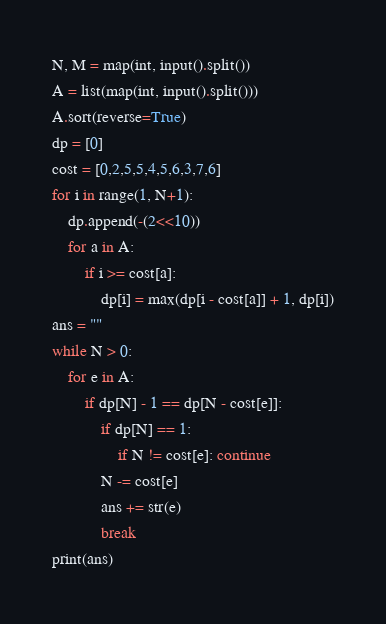Convert code to text. <code><loc_0><loc_0><loc_500><loc_500><_Python_>N, M = map(int, input().split())
A = list(map(int, input().split()))
A.sort(reverse=True)
dp = [0]
cost = [0,2,5,5,4,5,6,3,7,6]
for i in range(1, N+1):
    dp.append(-(2<<10))
    for a in A:
        if i >= cost[a]: 
            dp[i] = max(dp[i - cost[a]] + 1, dp[i])
ans = ""
while N > 0:
    for e in A:
        if dp[N] - 1 == dp[N - cost[e]]:
            if dp[N] == 1:
                if N != cost[e]: continue
            N -= cost[e]
            ans += str(e)
            break
print(ans)</code> 